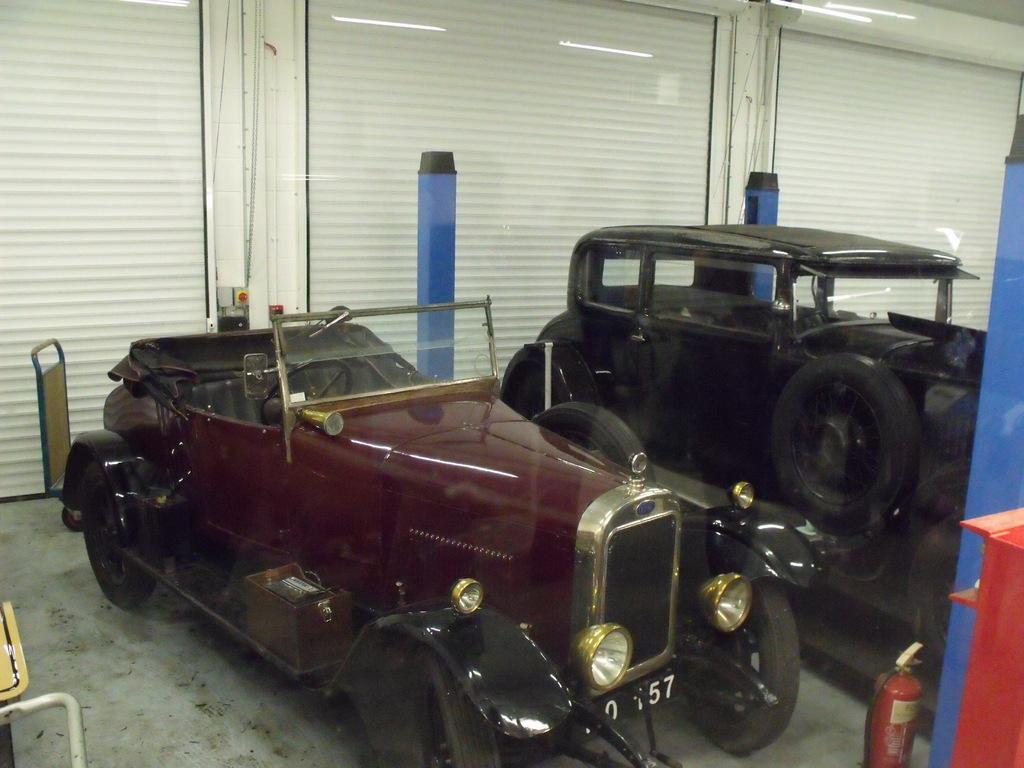How would you summarize this image in a sentence or two? There are two vehicles and this is a fire extinguisher. In the background there are shutters and lights. 